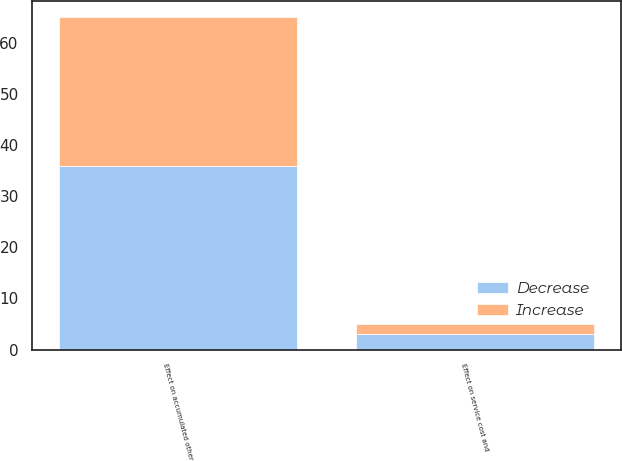Convert chart. <chart><loc_0><loc_0><loc_500><loc_500><stacked_bar_chart><ecel><fcel>Effect on accumulated other<fcel>Effect on service cost and<nl><fcel>Decrease<fcel>36<fcel>3<nl><fcel>Increase<fcel>29<fcel>2<nl></chart> 